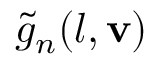<formula> <loc_0><loc_0><loc_500><loc_500>\tilde { g } _ { n } ( l , { v } )</formula> 